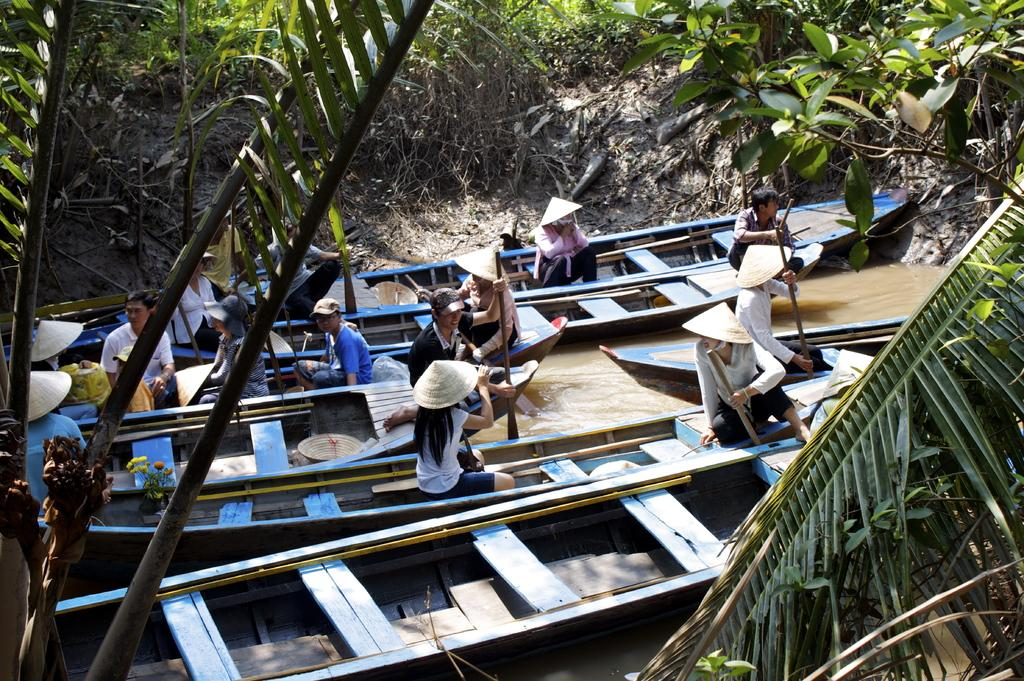What are the people in the image doing? The people in the image are sitting on boats. Where are the boats located? The boats are on the water. What type of vegetation can be seen in the image? There are plants and trees visible in the image. What committee is responsible for managing the territory in the image? There is no committee or territory mentioned in the image; it features a group of people sitting on boats on the water. What type of stick can be seen in the hands of the people in the image? There is no stick visible in the hands of the people in the image. 